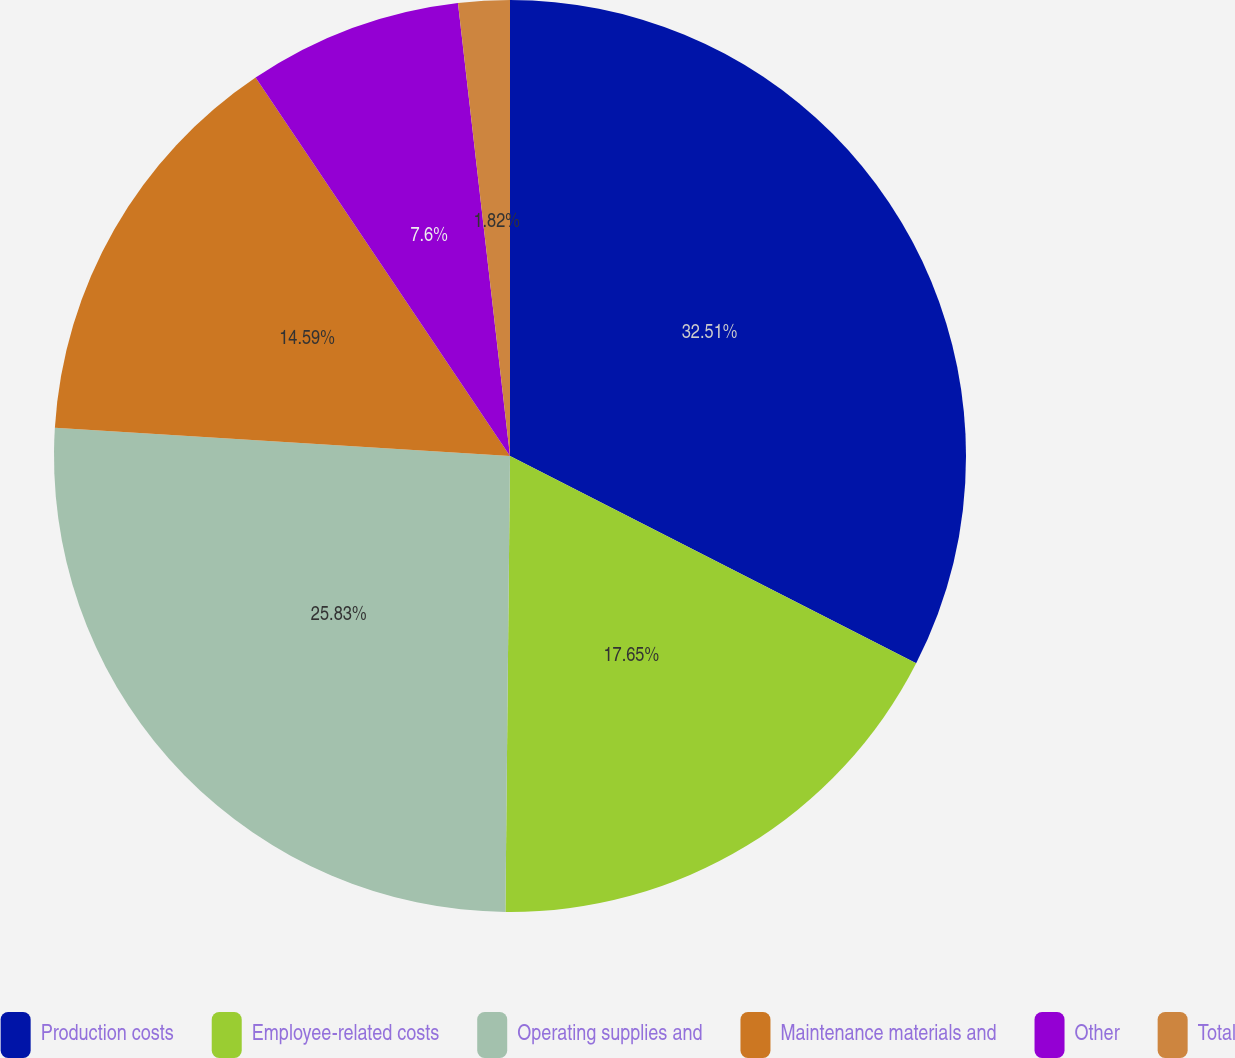<chart> <loc_0><loc_0><loc_500><loc_500><pie_chart><fcel>Production costs<fcel>Employee-related costs<fcel>Operating supplies and<fcel>Maintenance materials and<fcel>Other<fcel>Total<nl><fcel>32.51%<fcel>17.65%<fcel>25.83%<fcel>14.59%<fcel>7.6%<fcel>1.82%<nl></chart> 